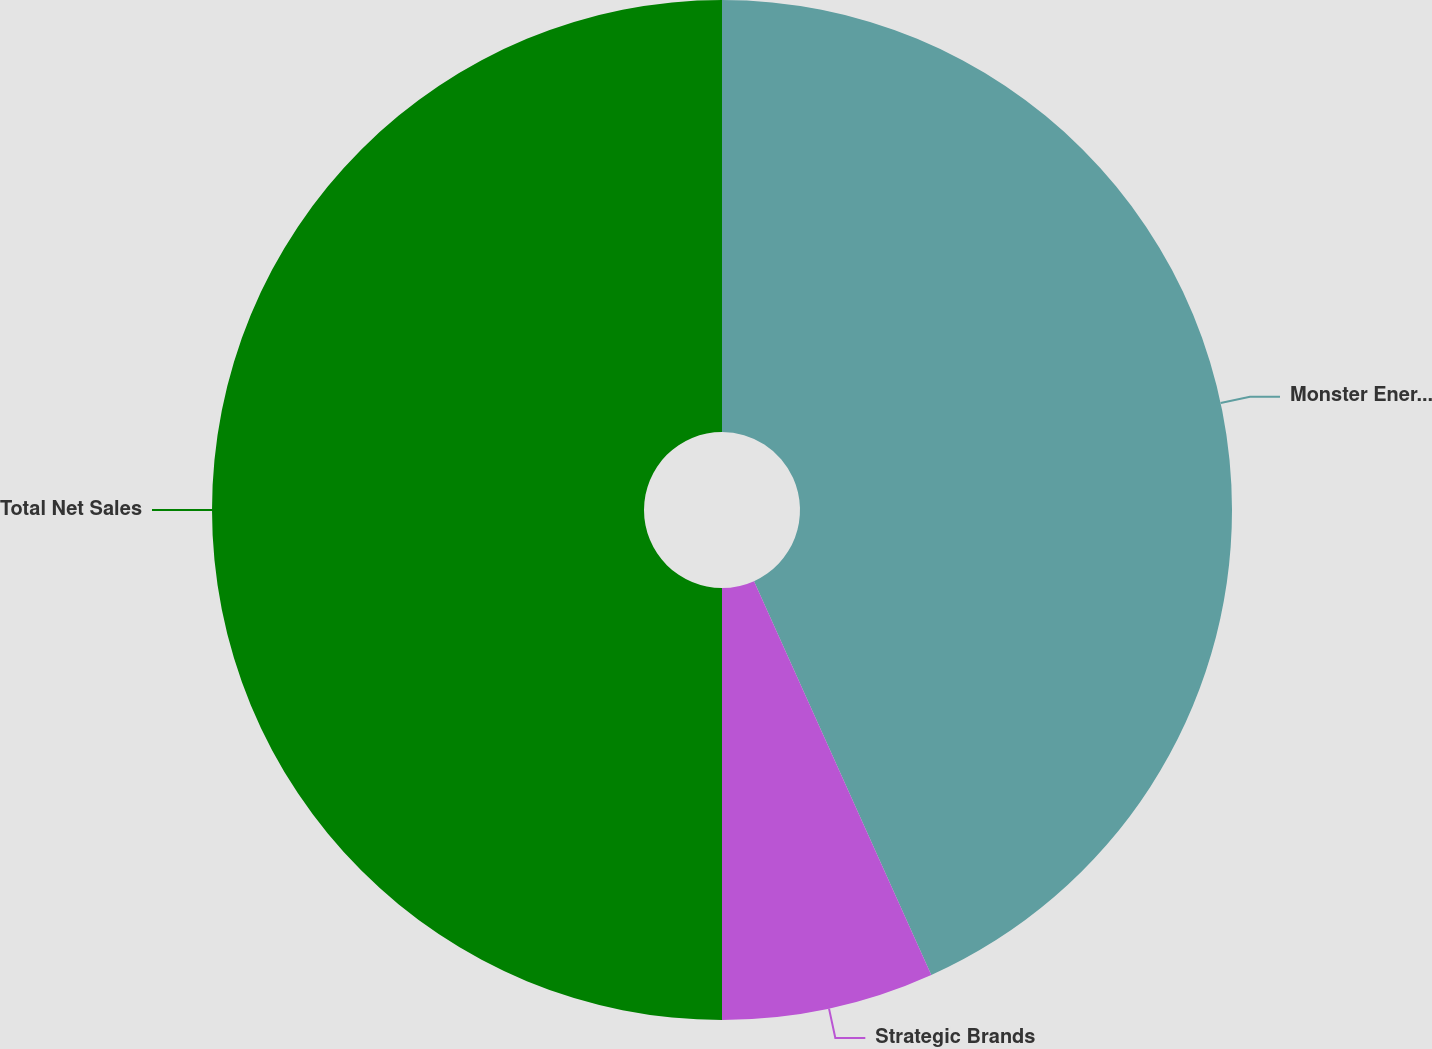Convert chart to OTSL. <chart><loc_0><loc_0><loc_500><loc_500><pie_chart><fcel>Monster Energy® Drinks<fcel>Strategic Brands<fcel>Total Net Sales<nl><fcel>43.27%<fcel>6.73%<fcel>50.0%<nl></chart> 